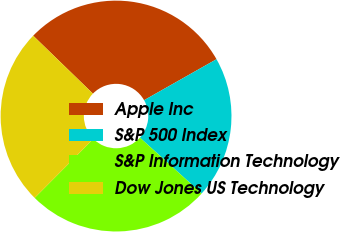Convert chart to OTSL. <chart><loc_0><loc_0><loc_500><loc_500><pie_chart><fcel>Apple Inc<fcel>S&P 500 Index<fcel>S&P Information Technology<fcel>Dow Jones US Technology<nl><fcel>29.55%<fcel>19.9%<fcel>25.75%<fcel>24.79%<nl></chart> 